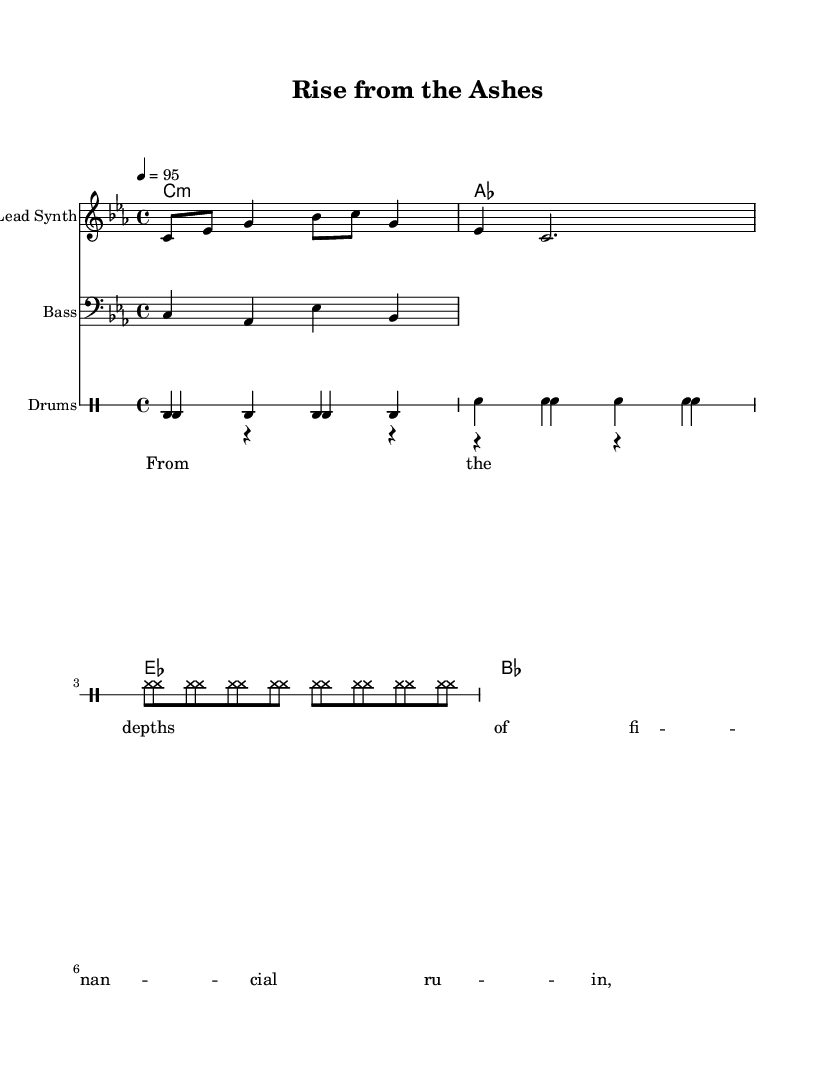What is the key signature of this music? The key signature indicated in the score is C minor, which has three flats (B♭, E♭, A♭). This can be identified at the beginning of the staff where the flats are placed.
Answer: C minor What is the time signature of this music? The time signature shown in the sheet music is 4/4, which means there are four beats in each measure and the quarter note gets one beat. This is denoted at the beginning of the score.
Answer: 4/4 What is the tempo marking for this piece? The tempo marking in the score is set at 95 beats per minute, which is indicated by the notation "4 = 95" at the beginning of the global settings.
Answer: 95 How many measures are in the melody? The melody contains a total of 3 measures, which can be counted from the beginning of the melody line until the end, each section separated by vertical bar lines.
Answer: 3 What is the name of the instrument for the lead part? The instrument for the lead part is specified as "Lead Synth" in the score's staff designation, which indicates that this staff is meant for a synthetic sound typically used in rap.
Answer: Lead Synth What style of music does this piece represent? This piece represents rap music, which is identified through its rhythmic structure, lyrical character, and overall genre context suggested by the thematic content about economic hardship and rebuilding.
Answer: Rap What lyrics start the song? The lyrics at the beginning of the song are "From the depths of financial ruin," which can be found written within the lyrics section of the score.
Answer: From the depths of financial ruin 